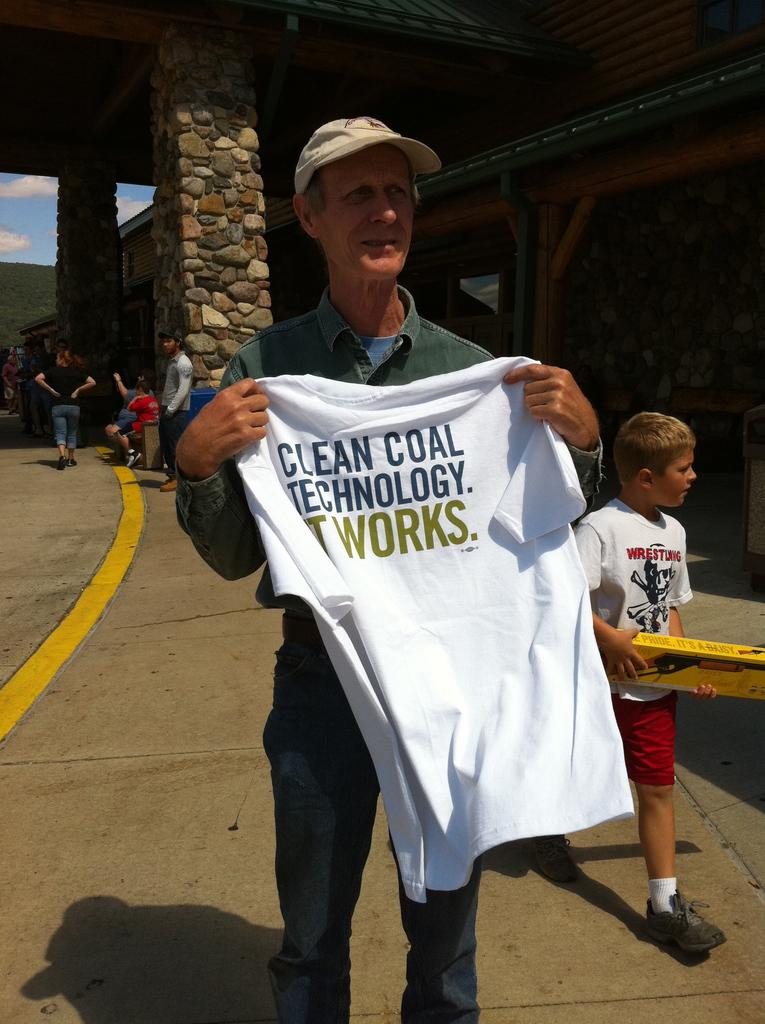Provide a one-sentence caption for the provided image. A man holds up a t-shirt advertising for clean coal technology. 